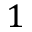Convert formula to latex. <formula><loc_0><loc_0><loc_500><loc_500>1</formula> 